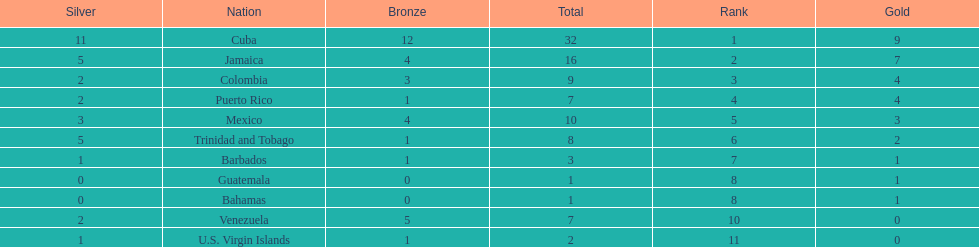Largest medal differential between countries 31. 